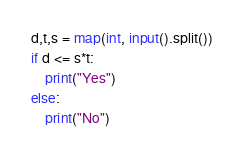<code> <loc_0><loc_0><loc_500><loc_500><_Python_>d,t,s = map(int, input().split())
if d <= s*t:
    print("Yes")
else:
    print("No")
</code> 